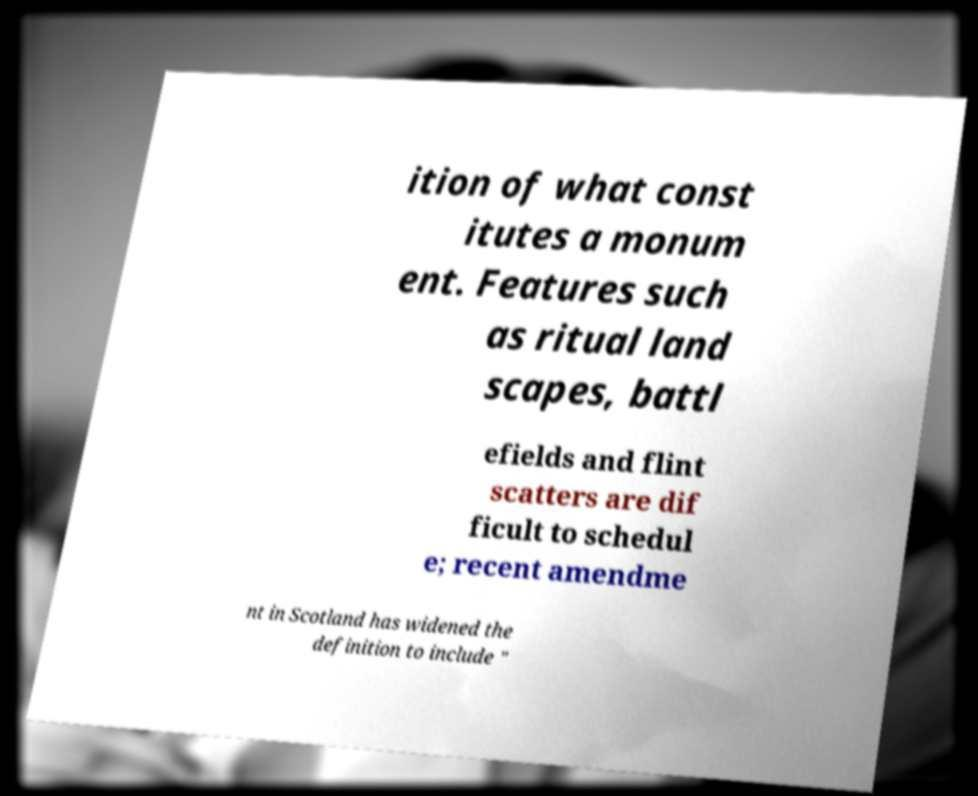There's text embedded in this image that I need extracted. Can you transcribe it verbatim? ition of what const itutes a monum ent. Features such as ritual land scapes, battl efields and flint scatters are dif ficult to schedul e; recent amendme nt in Scotland has widened the definition to include " 